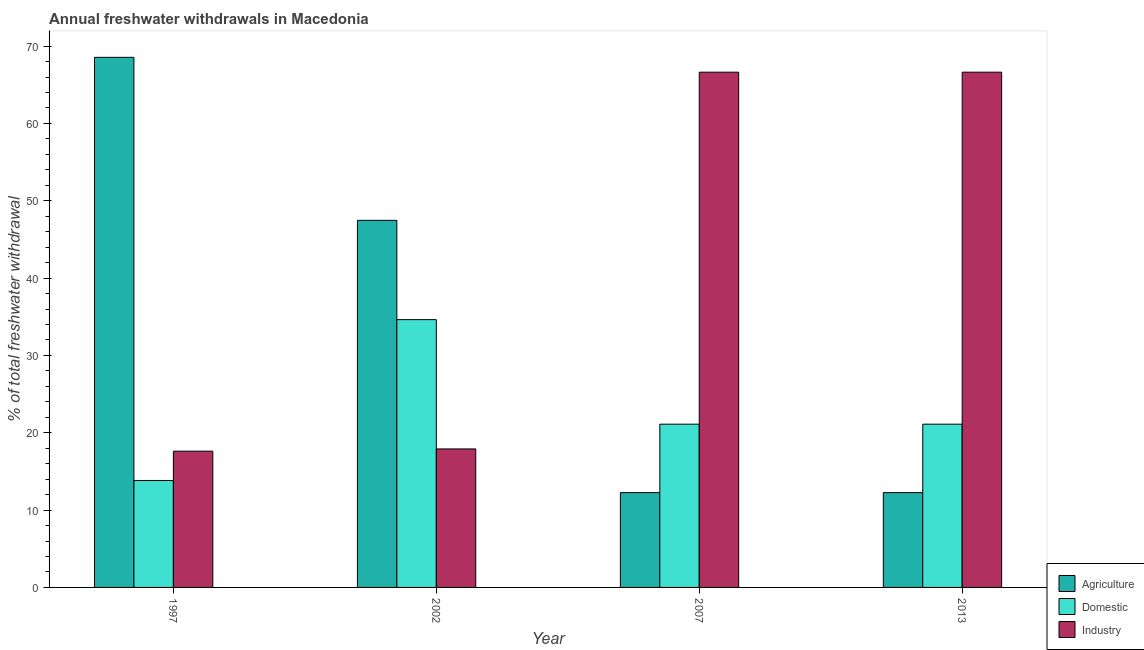How many different coloured bars are there?
Your answer should be compact. 3. How many groups of bars are there?
Provide a short and direct response. 4. Are the number of bars per tick equal to the number of legend labels?
Provide a succinct answer. Yes. Are the number of bars on each tick of the X-axis equal?
Give a very brief answer. Yes. How many bars are there on the 2nd tick from the left?
Offer a very short reply. 3. What is the label of the 4th group of bars from the left?
Offer a terse response. 2013. In how many cases, is the number of bars for a given year not equal to the number of legend labels?
Offer a very short reply. 0. What is the percentage of freshwater withdrawal for industry in 2002?
Provide a succinct answer. 17.91. Across all years, what is the maximum percentage of freshwater withdrawal for industry?
Keep it short and to the point. 66.63. Across all years, what is the minimum percentage of freshwater withdrawal for industry?
Your answer should be compact. 17.62. In which year was the percentage of freshwater withdrawal for domestic purposes maximum?
Your response must be concise. 2002. What is the total percentage of freshwater withdrawal for industry in the graph?
Provide a succinct answer. 168.79. What is the difference between the percentage of freshwater withdrawal for agriculture in 2002 and that in 2013?
Keep it short and to the point. 35.21. What is the difference between the percentage of freshwater withdrawal for domestic purposes in 2013 and the percentage of freshwater withdrawal for agriculture in 1997?
Your response must be concise. 7.28. What is the average percentage of freshwater withdrawal for agriculture per year?
Make the answer very short. 35.13. What is the ratio of the percentage of freshwater withdrawal for domestic purposes in 2002 to that in 2007?
Your response must be concise. 1.64. Is the difference between the percentage of freshwater withdrawal for agriculture in 1997 and 2013 greater than the difference between the percentage of freshwater withdrawal for domestic purposes in 1997 and 2013?
Offer a terse response. No. What is the difference between the highest and the second highest percentage of freshwater withdrawal for domestic purposes?
Provide a short and direct response. 13.52. What is the difference between the highest and the lowest percentage of freshwater withdrawal for industry?
Keep it short and to the point. 49.01. In how many years, is the percentage of freshwater withdrawal for agriculture greater than the average percentage of freshwater withdrawal for agriculture taken over all years?
Your response must be concise. 2. What does the 2nd bar from the left in 2002 represents?
Your response must be concise. Domestic. What does the 3rd bar from the right in 1997 represents?
Your answer should be compact. Agriculture. Is it the case that in every year, the sum of the percentage of freshwater withdrawal for agriculture and percentage of freshwater withdrawal for domestic purposes is greater than the percentage of freshwater withdrawal for industry?
Offer a terse response. No. Are all the bars in the graph horizontal?
Offer a terse response. No. What is the difference between two consecutive major ticks on the Y-axis?
Your answer should be very brief. 10. Does the graph contain any zero values?
Offer a very short reply. No. Does the graph contain grids?
Give a very brief answer. No. Where does the legend appear in the graph?
Your response must be concise. Bottom right. What is the title of the graph?
Provide a short and direct response. Annual freshwater withdrawals in Macedonia. Does "Fuel" appear as one of the legend labels in the graph?
Give a very brief answer. No. What is the label or title of the X-axis?
Give a very brief answer. Year. What is the label or title of the Y-axis?
Offer a very short reply. % of total freshwater withdrawal. What is the % of total freshwater withdrawal in Agriculture in 1997?
Offer a terse response. 68.55. What is the % of total freshwater withdrawal of Domestic in 1997?
Make the answer very short. 13.83. What is the % of total freshwater withdrawal of Industry in 1997?
Your answer should be very brief. 17.62. What is the % of total freshwater withdrawal of Agriculture in 2002?
Provide a succinct answer. 47.47. What is the % of total freshwater withdrawal in Domestic in 2002?
Make the answer very short. 34.63. What is the % of total freshwater withdrawal of Industry in 2002?
Keep it short and to the point. 17.91. What is the % of total freshwater withdrawal of Agriculture in 2007?
Your answer should be very brief. 12.26. What is the % of total freshwater withdrawal in Domestic in 2007?
Offer a very short reply. 21.11. What is the % of total freshwater withdrawal in Industry in 2007?
Your answer should be very brief. 66.63. What is the % of total freshwater withdrawal in Agriculture in 2013?
Your answer should be very brief. 12.26. What is the % of total freshwater withdrawal of Domestic in 2013?
Your answer should be very brief. 21.11. What is the % of total freshwater withdrawal of Industry in 2013?
Your response must be concise. 66.63. Across all years, what is the maximum % of total freshwater withdrawal of Agriculture?
Your answer should be compact. 68.55. Across all years, what is the maximum % of total freshwater withdrawal of Domestic?
Offer a terse response. 34.63. Across all years, what is the maximum % of total freshwater withdrawal in Industry?
Offer a terse response. 66.63. Across all years, what is the minimum % of total freshwater withdrawal in Agriculture?
Offer a terse response. 12.26. Across all years, what is the minimum % of total freshwater withdrawal of Domestic?
Your answer should be very brief. 13.83. Across all years, what is the minimum % of total freshwater withdrawal in Industry?
Provide a succinct answer. 17.62. What is the total % of total freshwater withdrawal in Agriculture in the graph?
Offer a very short reply. 140.54. What is the total % of total freshwater withdrawal in Domestic in the graph?
Keep it short and to the point. 90.68. What is the total % of total freshwater withdrawal in Industry in the graph?
Ensure brevity in your answer.  168.79. What is the difference between the % of total freshwater withdrawal of Agriculture in 1997 and that in 2002?
Provide a succinct answer. 21.08. What is the difference between the % of total freshwater withdrawal of Domestic in 1997 and that in 2002?
Your answer should be compact. -20.8. What is the difference between the % of total freshwater withdrawal of Industry in 1997 and that in 2002?
Your answer should be compact. -0.29. What is the difference between the % of total freshwater withdrawal of Agriculture in 1997 and that in 2007?
Offer a very short reply. 56.29. What is the difference between the % of total freshwater withdrawal in Domestic in 1997 and that in 2007?
Offer a very short reply. -7.28. What is the difference between the % of total freshwater withdrawal in Industry in 1997 and that in 2007?
Offer a very short reply. -49.01. What is the difference between the % of total freshwater withdrawal of Agriculture in 1997 and that in 2013?
Your response must be concise. 56.29. What is the difference between the % of total freshwater withdrawal in Domestic in 1997 and that in 2013?
Offer a very short reply. -7.28. What is the difference between the % of total freshwater withdrawal in Industry in 1997 and that in 2013?
Give a very brief answer. -49.01. What is the difference between the % of total freshwater withdrawal in Agriculture in 2002 and that in 2007?
Give a very brief answer. 35.21. What is the difference between the % of total freshwater withdrawal of Domestic in 2002 and that in 2007?
Offer a very short reply. 13.52. What is the difference between the % of total freshwater withdrawal of Industry in 2002 and that in 2007?
Make the answer very short. -48.72. What is the difference between the % of total freshwater withdrawal of Agriculture in 2002 and that in 2013?
Ensure brevity in your answer.  35.21. What is the difference between the % of total freshwater withdrawal in Domestic in 2002 and that in 2013?
Provide a succinct answer. 13.52. What is the difference between the % of total freshwater withdrawal in Industry in 2002 and that in 2013?
Provide a succinct answer. -48.72. What is the difference between the % of total freshwater withdrawal in Agriculture in 2007 and that in 2013?
Your response must be concise. 0. What is the difference between the % of total freshwater withdrawal of Domestic in 2007 and that in 2013?
Your answer should be compact. 0. What is the difference between the % of total freshwater withdrawal of Industry in 2007 and that in 2013?
Offer a terse response. 0. What is the difference between the % of total freshwater withdrawal of Agriculture in 1997 and the % of total freshwater withdrawal of Domestic in 2002?
Offer a very short reply. 33.92. What is the difference between the % of total freshwater withdrawal of Agriculture in 1997 and the % of total freshwater withdrawal of Industry in 2002?
Make the answer very short. 50.64. What is the difference between the % of total freshwater withdrawal of Domestic in 1997 and the % of total freshwater withdrawal of Industry in 2002?
Give a very brief answer. -4.08. What is the difference between the % of total freshwater withdrawal of Agriculture in 1997 and the % of total freshwater withdrawal of Domestic in 2007?
Your response must be concise. 47.44. What is the difference between the % of total freshwater withdrawal in Agriculture in 1997 and the % of total freshwater withdrawal in Industry in 2007?
Provide a short and direct response. 1.92. What is the difference between the % of total freshwater withdrawal of Domestic in 1997 and the % of total freshwater withdrawal of Industry in 2007?
Keep it short and to the point. -52.8. What is the difference between the % of total freshwater withdrawal of Agriculture in 1997 and the % of total freshwater withdrawal of Domestic in 2013?
Provide a short and direct response. 47.44. What is the difference between the % of total freshwater withdrawal in Agriculture in 1997 and the % of total freshwater withdrawal in Industry in 2013?
Your answer should be very brief. 1.92. What is the difference between the % of total freshwater withdrawal of Domestic in 1997 and the % of total freshwater withdrawal of Industry in 2013?
Provide a short and direct response. -52.8. What is the difference between the % of total freshwater withdrawal in Agriculture in 2002 and the % of total freshwater withdrawal in Domestic in 2007?
Your answer should be compact. 26.36. What is the difference between the % of total freshwater withdrawal of Agriculture in 2002 and the % of total freshwater withdrawal of Industry in 2007?
Provide a succinct answer. -19.16. What is the difference between the % of total freshwater withdrawal of Domestic in 2002 and the % of total freshwater withdrawal of Industry in 2007?
Your response must be concise. -32. What is the difference between the % of total freshwater withdrawal of Agriculture in 2002 and the % of total freshwater withdrawal of Domestic in 2013?
Your response must be concise. 26.36. What is the difference between the % of total freshwater withdrawal in Agriculture in 2002 and the % of total freshwater withdrawal in Industry in 2013?
Your response must be concise. -19.16. What is the difference between the % of total freshwater withdrawal of Domestic in 2002 and the % of total freshwater withdrawal of Industry in 2013?
Provide a succinct answer. -32. What is the difference between the % of total freshwater withdrawal of Agriculture in 2007 and the % of total freshwater withdrawal of Domestic in 2013?
Provide a succinct answer. -8.85. What is the difference between the % of total freshwater withdrawal in Agriculture in 2007 and the % of total freshwater withdrawal in Industry in 2013?
Offer a terse response. -54.37. What is the difference between the % of total freshwater withdrawal in Domestic in 2007 and the % of total freshwater withdrawal in Industry in 2013?
Your response must be concise. -45.52. What is the average % of total freshwater withdrawal of Agriculture per year?
Offer a terse response. 35.13. What is the average % of total freshwater withdrawal in Domestic per year?
Ensure brevity in your answer.  22.67. What is the average % of total freshwater withdrawal in Industry per year?
Offer a very short reply. 42.2. In the year 1997, what is the difference between the % of total freshwater withdrawal of Agriculture and % of total freshwater withdrawal of Domestic?
Ensure brevity in your answer.  54.72. In the year 1997, what is the difference between the % of total freshwater withdrawal in Agriculture and % of total freshwater withdrawal in Industry?
Offer a very short reply. 50.93. In the year 1997, what is the difference between the % of total freshwater withdrawal in Domestic and % of total freshwater withdrawal in Industry?
Your answer should be very brief. -3.79. In the year 2002, what is the difference between the % of total freshwater withdrawal in Agriculture and % of total freshwater withdrawal in Domestic?
Your answer should be compact. 12.84. In the year 2002, what is the difference between the % of total freshwater withdrawal in Agriculture and % of total freshwater withdrawal in Industry?
Provide a short and direct response. 29.56. In the year 2002, what is the difference between the % of total freshwater withdrawal of Domestic and % of total freshwater withdrawal of Industry?
Make the answer very short. 16.72. In the year 2007, what is the difference between the % of total freshwater withdrawal of Agriculture and % of total freshwater withdrawal of Domestic?
Provide a succinct answer. -8.85. In the year 2007, what is the difference between the % of total freshwater withdrawal of Agriculture and % of total freshwater withdrawal of Industry?
Your response must be concise. -54.37. In the year 2007, what is the difference between the % of total freshwater withdrawal in Domestic and % of total freshwater withdrawal in Industry?
Your answer should be very brief. -45.52. In the year 2013, what is the difference between the % of total freshwater withdrawal in Agriculture and % of total freshwater withdrawal in Domestic?
Make the answer very short. -8.85. In the year 2013, what is the difference between the % of total freshwater withdrawal of Agriculture and % of total freshwater withdrawal of Industry?
Your answer should be compact. -54.37. In the year 2013, what is the difference between the % of total freshwater withdrawal of Domestic and % of total freshwater withdrawal of Industry?
Your response must be concise. -45.52. What is the ratio of the % of total freshwater withdrawal of Agriculture in 1997 to that in 2002?
Your response must be concise. 1.44. What is the ratio of the % of total freshwater withdrawal in Domestic in 1997 to that in 2002?
Offer a terse response. 0.4. What is the ratio of the % of total freshwater withdrawal in Industry in 1997 to that in 2002?
Keep it short and to the point. 0.98. What is the ratio of the % of total freshwater withdrawal in Agriculture in 1997 to that in 2007?
Offer a very short reply. 5.59. What is the ratio of the % of total freshwater withdrawal of Domestic in 1997 to that in 2007?
Give a very brief answer. 0.66. What is the ratio of the % of total freshwater withdrawal in Industry in 1997 to that in 2007?
Keep it short and to the point. 0.26. What is the ratio of the % of total freshwater withdrawal in Agriculture in 1997 to that in 2013?
Keep it short and to the point. 5.59. What is the ratio of the % of total freshwater withdrawal in Domestic in 1997 to that in 2013?
Ensure brevity in your answer.  0.66. What is the ratio of the % of total freshwater withdrawal in Industry in 1997 to that in 2013?
Make the answer very short. 0.26. What is the ratio of the % of total freshwater withdrawal in Agriculture in 2002 to that in 2007?
Offer a terse response. 3.87. What is the ratio of the % of total freshwater withdrawal of Domestic in 2002 to that in 2007?
Provide a succinct answer. 1.64. What is the ratio of the % of total freshwater withdrawal in Industry in 2002 to that in 2007?
Ensure brevity in your answer.  0.27. What is the ratio of the % of total freshwater withdrawal in Agriculture in 2002 to that in 2013?
Give a very brief answer. 3.87. What is the ratio of the % of total freshwater withdrawal in Domestic in 2002 to that in 2013?
Your response must be concise. 1.64. What is the ratio of the % of total freshwater withdrawal of Industry in 2002 to that in 2013?
Provide a short and direct response. 0.27. What is the ratio of the % of total freshwater withdrawal in Agriculture in 2007 to that in 2013?
Provide a succinct answer. 1. What is the ratio of the % of total freshwater withdrawal of Domestic in 2007 to that in 2013?
Your response must be concise. 1. What is the ratio of the % of total freshwater withdrawal of Industry in 2007 to that in 2013?
Provide a short and direct response. 1. What is the difference between the highest and the second highest % of total freshwater withdrawal in Agriculture?
Make the answer very short. 21.08. What is the difference between the highest and the second highest % of total freshwater withdrawal in Domestic?
Keep it short and to the point. 13.52. What is the difference between the highest and the lowest % of total freshwater withdrawal of Agriculture?
Your answer should be very brief. 56.29. What is the difference between the highest and the lowest % of total freshwater withdrawal of Domestic?
Your answer should be very brief. 20.8. What is the difference between the highest and the lowest % of total freshwater withdrawal of Industry?
Offer a very short reply. 49.01. 